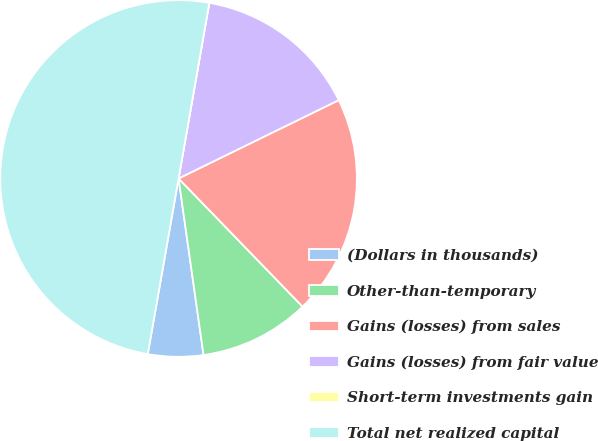Convert chart to OTSL. <chart><loc_0><loc_0><loc_500><loc_500><pie_chart><fcel>(Dollars in thousands)<fcel>Other-than-temporary<fcel>Gains (losses) from sales<fcel>Gains (losses) from fair value<fcel>Short-term investments gain<fcel>Total net realized capital<nl><fcel>5.0%<fcel>10.0%<fcel>20.0%<fcel>15.0%<fcel>0.0%<fcel>49.99%<nl></chart> 